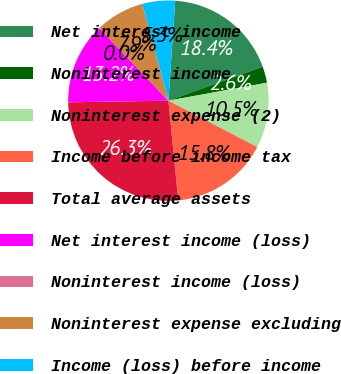Convert chart. <chart><loc_0><loc_0><loc_500><loc_500><pie_chart><fcel>Net interest income<fcel>Noninterest income<fcel>Noninterest expense (2)<fcel>Income before income tax<fcel>Total average assets<fcel>Net interest income (loss)<fcel>Noninterest income (loss)<fcel>Noninterest expense excluding<fcel>Income (loss) before income<nl><fcel>18.41%<fcel>2.64%<fcel>10.53%<fcel>15.78%<fcel>26.3%<fcel>13.16%<fcel>0.01%<fcel>7.9%<fcel>5.27%<nl></chart> 